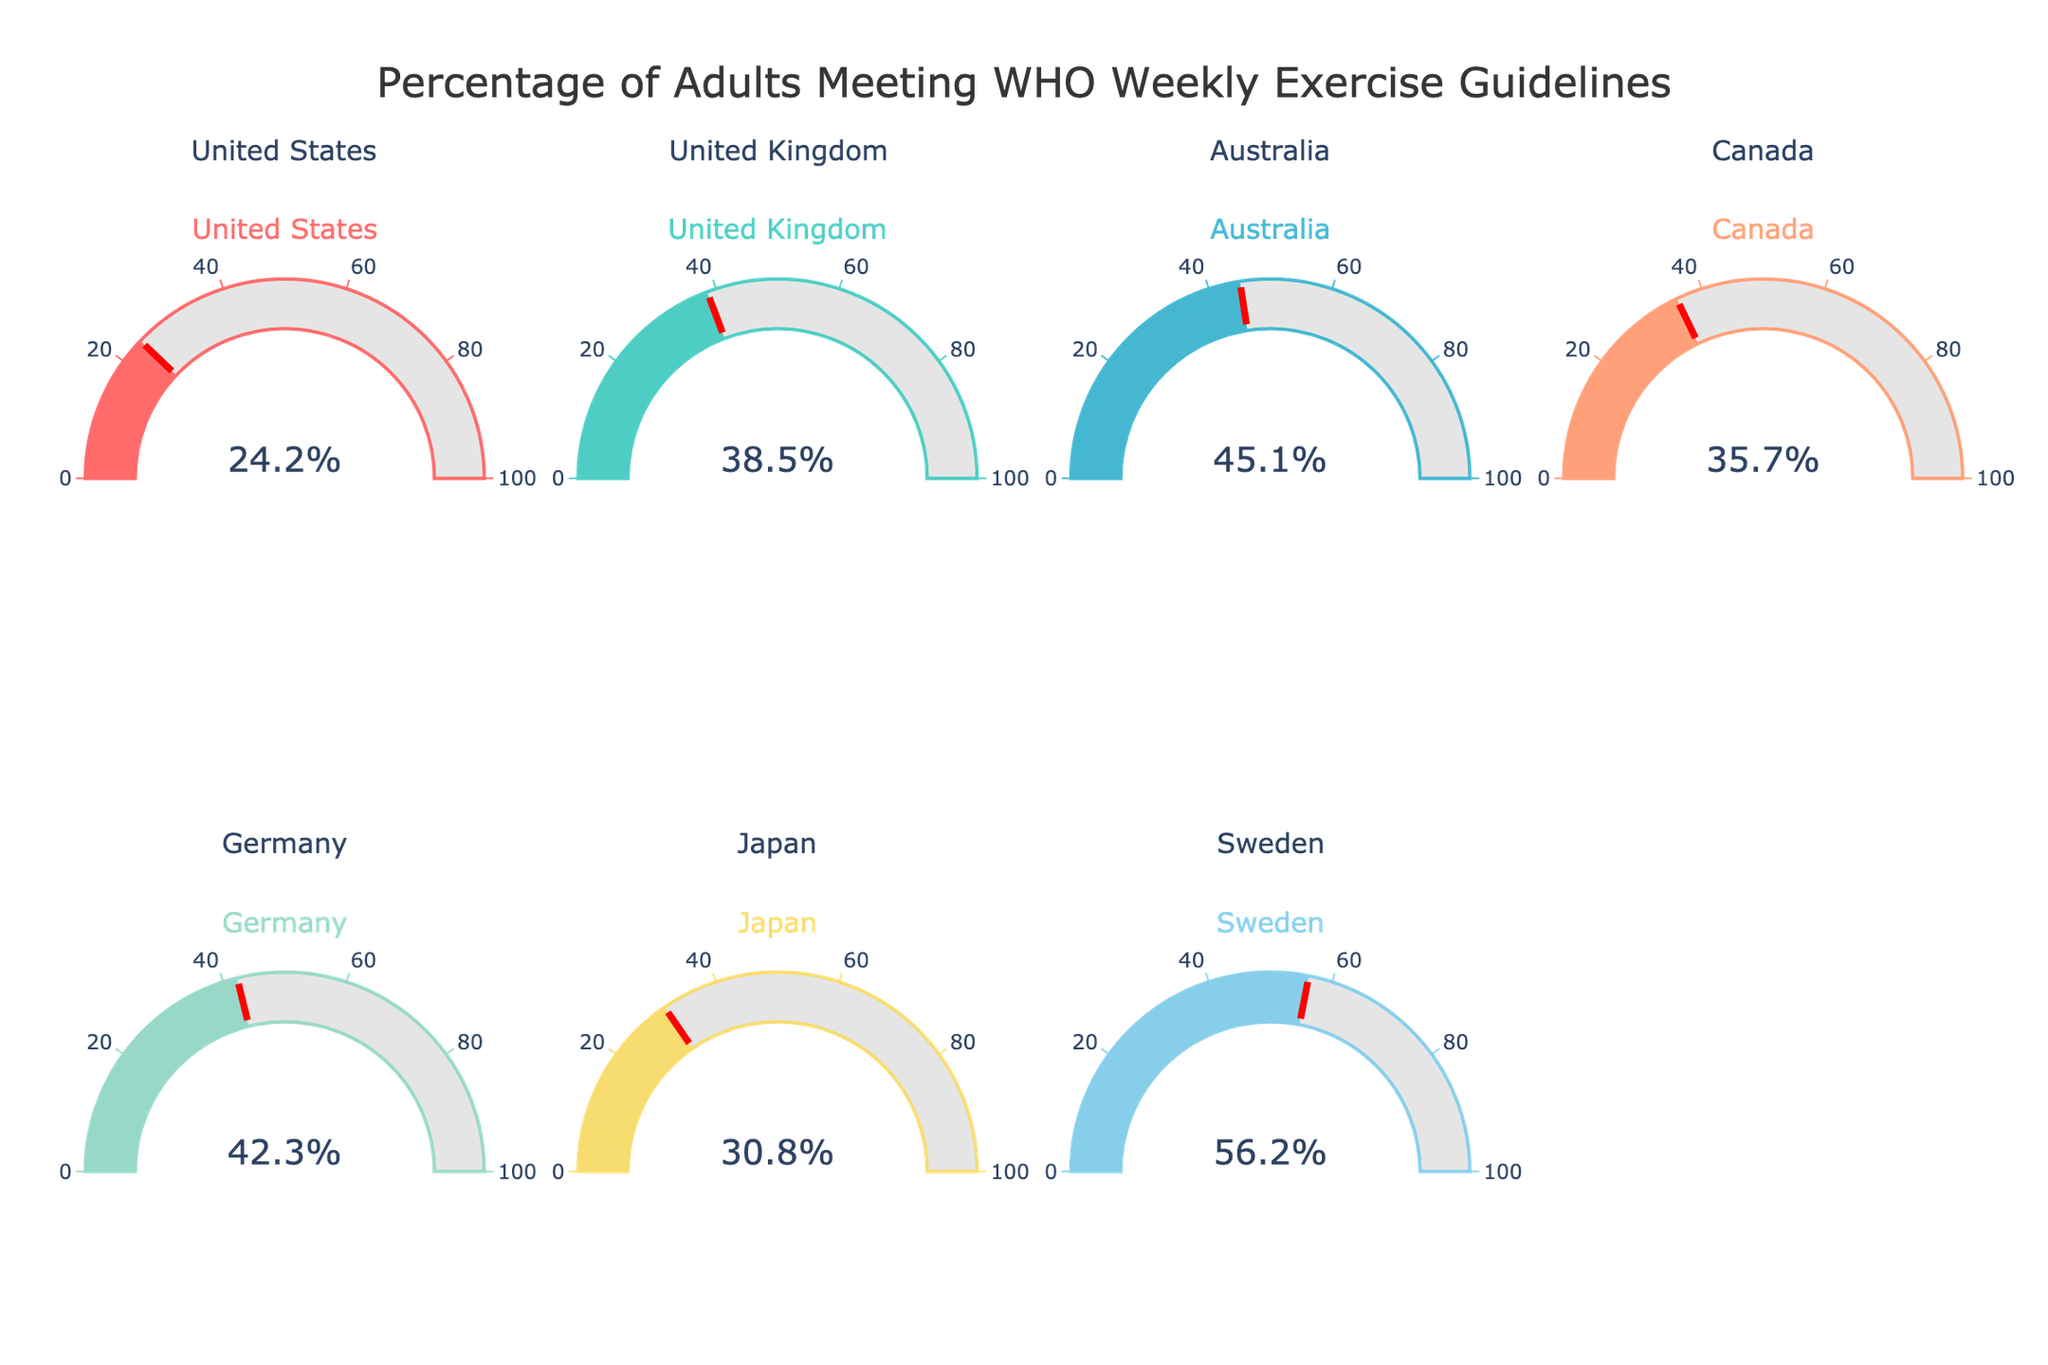What percentage of adults in the United States meet the WHO weekly exercise guidelines? The gauge chart for the United States indicates the percentage of adults meeting the WHO weekly exercise guidelines. The number displayed is 24.2%.
Answer: 24.2% Which country has the highest percentage of adults meeting the WHO weekly exercise guidelines? By inspecting all the gauge charts, we see that Sweden has the highest percentage, with 56.2%.
Answer: Sweden What's the average percentage of adults meeting the WHO weekly exercise guidelines across all the countries? Sum the percentages for all countries (24.2 + 38.5 + 45.1 + 35.7 + 42.3 + 30.8 + 56.2), which equals 272.8, and then divide by the number of countries (7). The average is 272.8 / 7 ≈ 39.0%.
Answer: 39.0% Which countries have a percentage of adults meeting the exercise guidelines greater than 40%? Inspecting the gauge charts, the countries with percentages greater than 40% are Australia (45.1%), Germany (42.3%), and Sweden (56.2%).
Answer: Australia, Germany, Sweden What is the difference in the percentage of adults meeting the WHO weekly exercise guidelines between the highest and lowest countries? The highest percentage is 56.2% (Sweden) and the lowest is 24.2% (United States). The difference is 56.2 - 24.2 = 32%.
Answer: 32% How many countries have a percentage of adults meeting the guidelines between 30% and 40%? The percentages that fall within 30% to 40% are from the United Kingdom (38.5%), Canada (35.7%), and Japan (30.8%). There are 3 such countries.
Answer: 3 Compare the percentage of the United Kingdom with Canada. Which country has a higher percentage? The gauge chart for the United Kingdom shows 38.5%, while Canada shows 35.7%. Hence, the United Kingdom has a higher percentage.
Answer: United Kingdom What is the total number of countries represented in the figure? By counting the number of gauge charts, we see that there are 7 countries.
Answer: 7 What percentage of adults in Germany meets the WHO weekly exercise guidelines? The gauge chart for Germany indicates the percentage of adults meeting the WHO weekly exercise guidelines. The number displayed is 42.3%.
Answer: 42.3% 